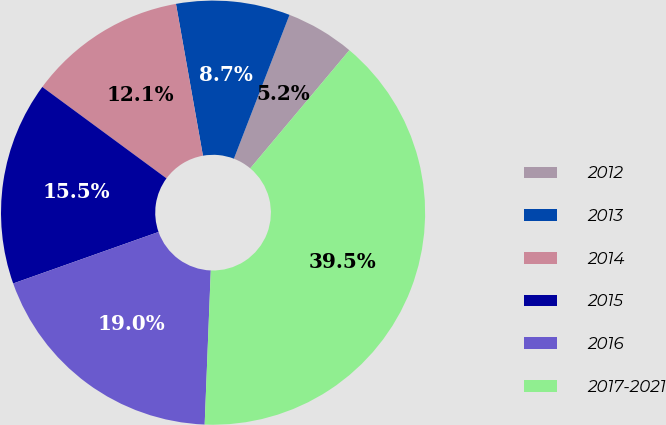Convert chart to OTSL. <chart><loc_0><loc_0><loc_500><loc_500><pie_chart><fcel>2012<fcel>2013<fcel>2014<fcel>2015<fcel>2016<fcel>2017-2021<nl><fcel>5.24%<fcel>8.67%<fcel>12.1%<fcel>15.52%<fcel>18.95%<fcel>39.52%<nl></chart> 